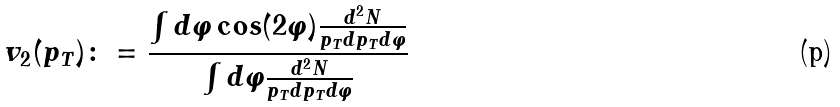<formula> <loc_0><loc_0><loc_500><loc_500>v _ { 2 } ( p _ { T } ) \colon = \frac { \int d \varphi \cos ( 2 \varphi ) \frac { d ^ { 2 } N } { p _ { T } d p _ { T } d \varphi } } { \int d \varphi \frac { d ^ { 2 } N } { p _ { T } d p _ { T } d \varphi } } \,</formula> 